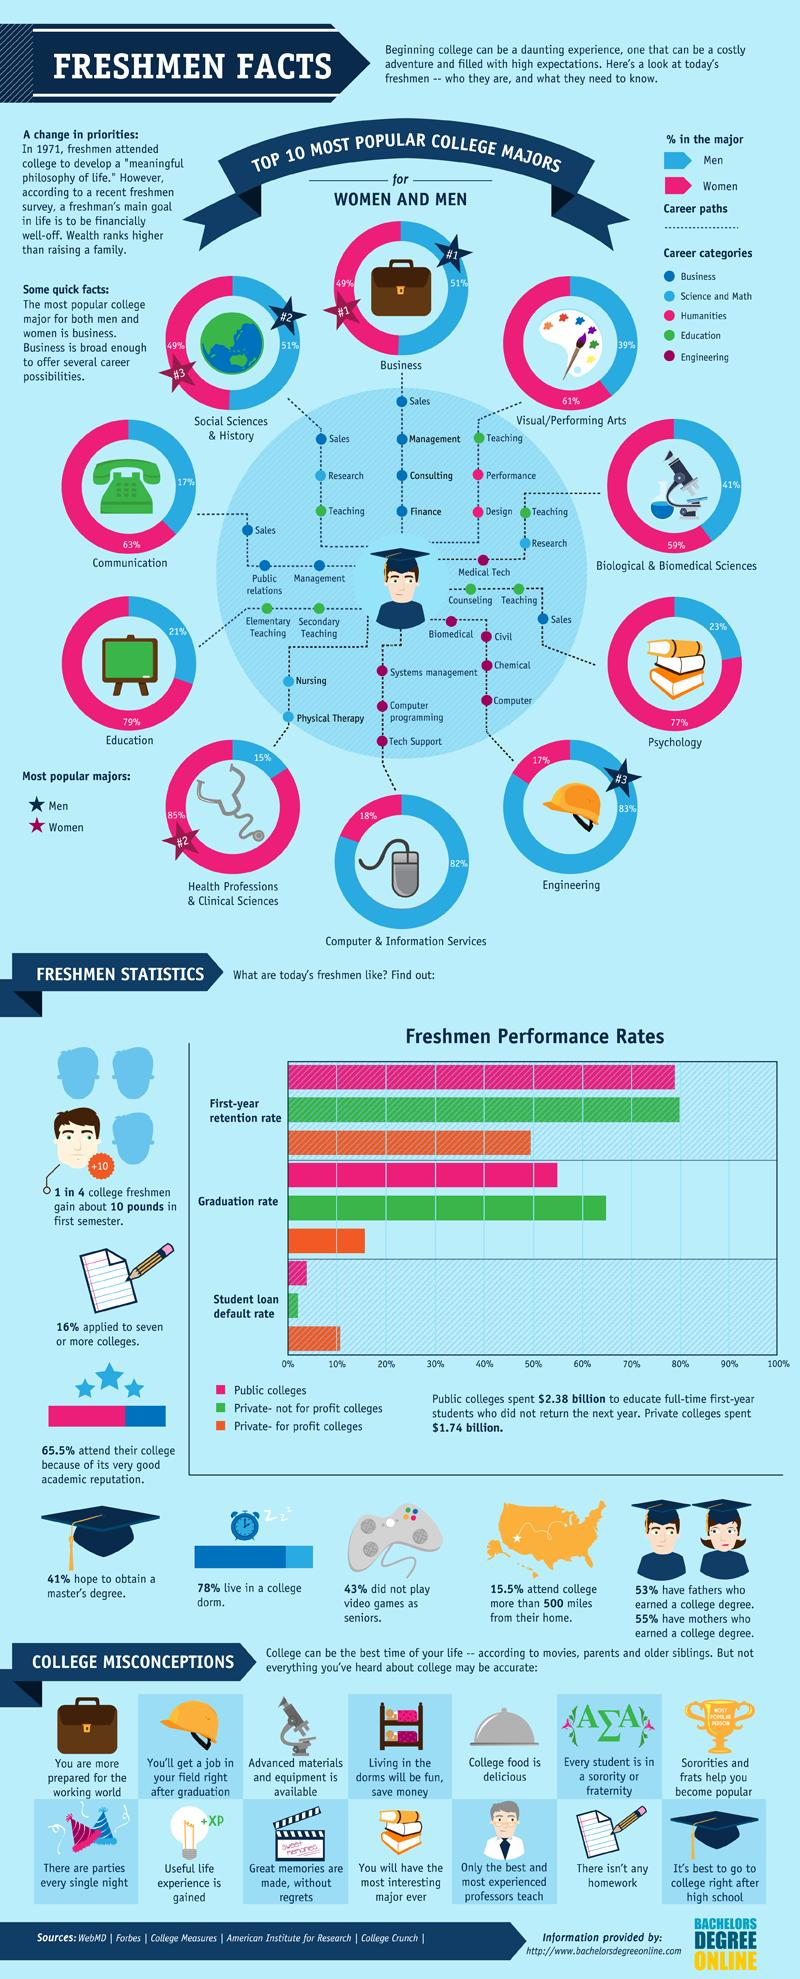Point out several critical features in this image. In psychology, men and women have approximately equal shares. The percentage of women in the Computer and Information Services industry is higher than that of men. There are three branches of psychology. There are 4 streams for Engineering. A recent study has found that 57% of seniors play video games. 